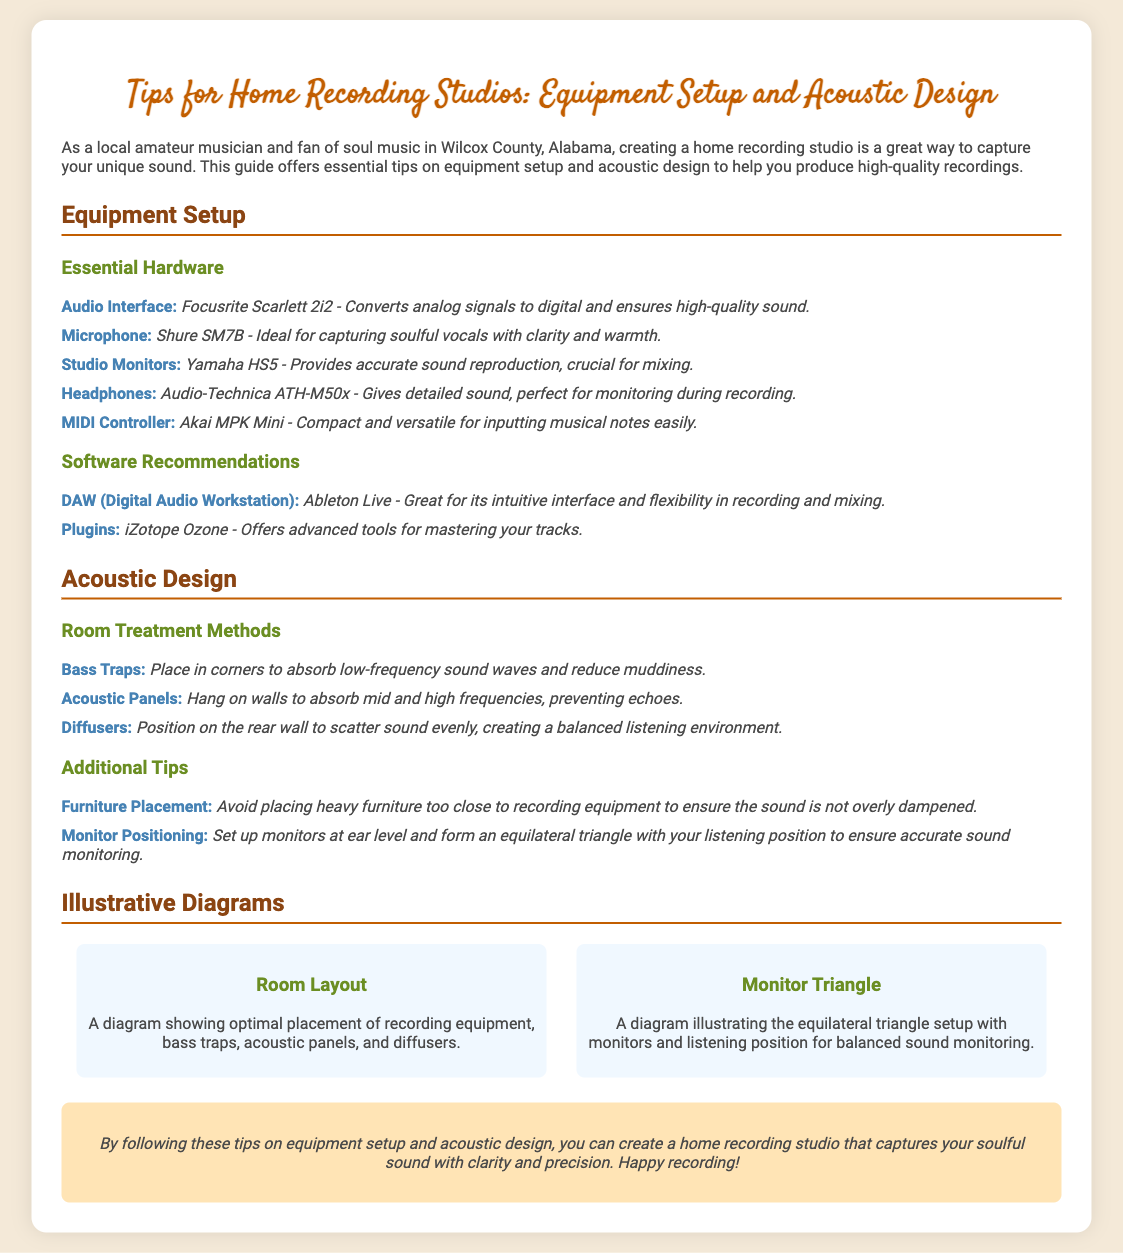what is the recommended audio interface? The document recommends the Focusrite Scarlett 2i2 as the audio interface, highlighting its role in converting analog signals to digital.
Answer: Focusrite Scarlett 2i2 which microphone is ideal for capturing soulful vocals? The document identifies the Shure SM7B microphone as ideal for capturing soulful vocals with clarity and warmth.
Answer: Shure SM7B what type of software is suggested for recording and mixing? The presentation suggests Ableton Live as the DAW (Digital Audio Workstation) for its intuitive interface and flexibility.
Answer: Ableton Live what is the purpose of bass traps? The document mentions that bass traps are used to absorb low-frequency sound waves and reduce muddiness.
Answer: Absorb low-frequency sound waves how should studio monitors be positioned? According to the document, studio monitors should be set up at ear level and form an equilateral triangle with the listening position for accurate sound monitoring.
Answer: Ear level and equilateral triangle what item is recommended for detailed sound monitoring? The document recommends Audio-Technica ATH-M50x headphones for their detailed sound suited for monitoring during recording.
Answer: Audio-Technica ATH-M50x how many methods of room treatment are discussed? There are three methods of room treatment mentioned: bass traps, acoustic panels, and diffusers.
Answer: Three what is the style of the presentation? The document is designed as a presentation slide with structured sections and illustrative diagrams aimed at providing tips for home recording studios.
Answer: Slide presentation 